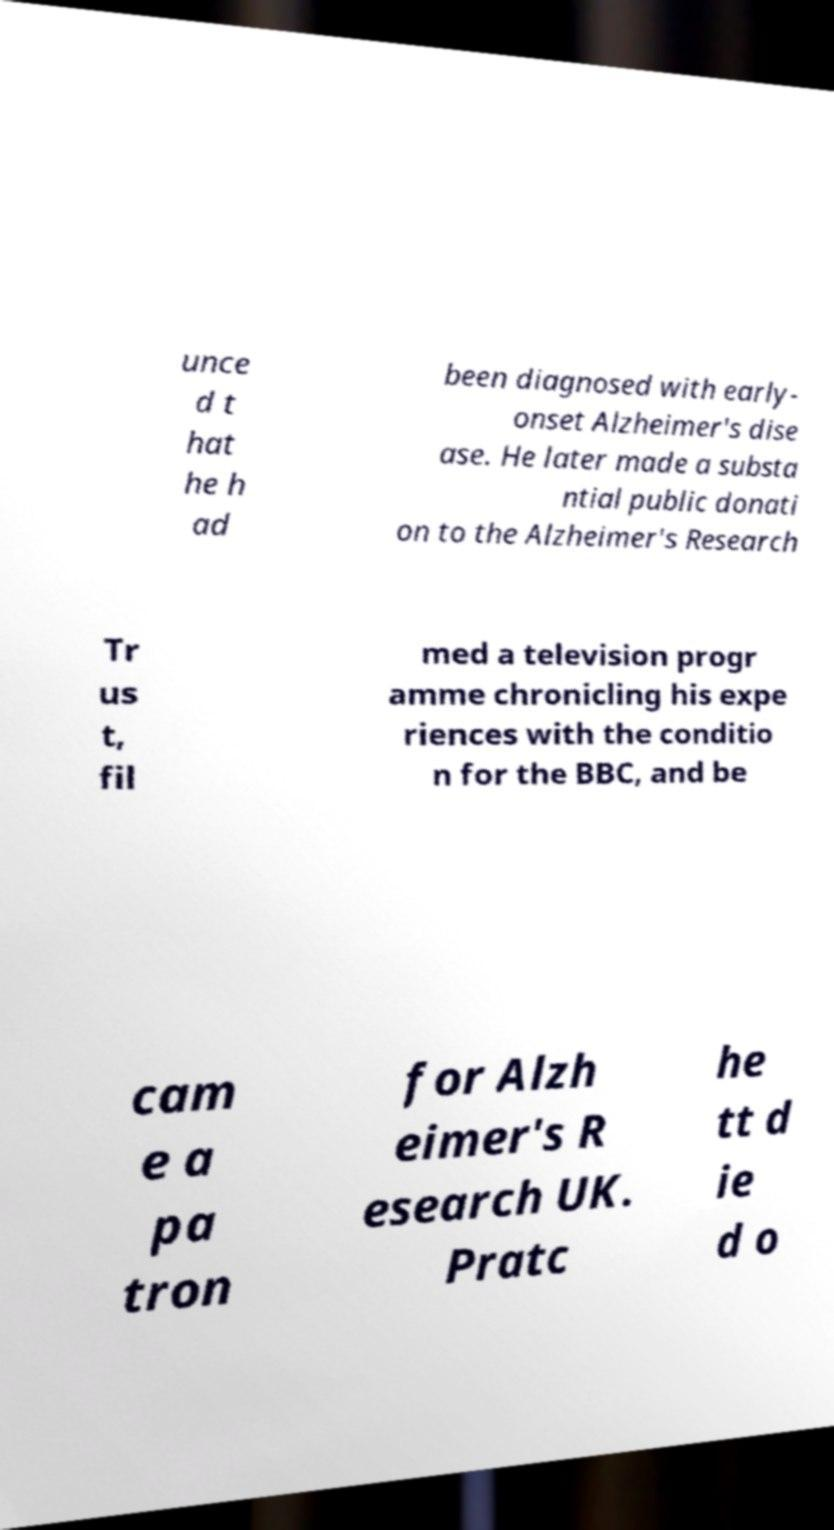There's text embedded in this image that I need extracted. Can you transcribe it verbatim? unce d t hat he h ad been diagnosed with early- onset Alzheimer's dise ase. He later made a substa ntial public donati on to the Alzheimer's Research Tr us t, fil med a television progr amme chronicling his expe riences with the conditio n for the BBC, and be cam e a pa tron for Alzh eimer's R esearch UK. Pratc he tt d ie d o 